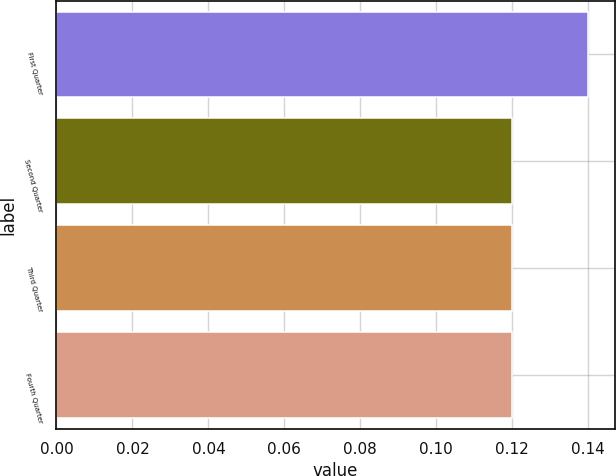Convert chart. <chart><loc_0><loc_0><loc_500><loc_500><bar_chart><fcel>First Quarter<fcel>Second Quarter<fcel>Third Quarter<fcel>Fourth Quarter<nl><fcel>0.14<fcel>0.12<fcel>0.12<fcel>0.12<nl></chart> 